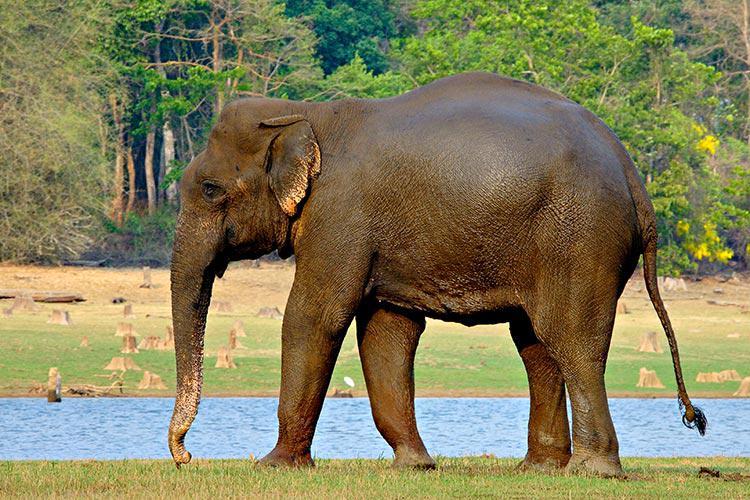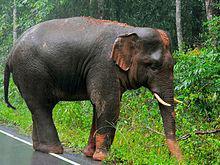The first image is the image on the left, the second image is the image on the right. Analyze the images presented: Is the assertion "There are two elephants in total." valid? Answer yes or no. Yes. 